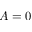<formula> <loc_0><loc_0><loc_500><loc_500>A = 0</formula> 